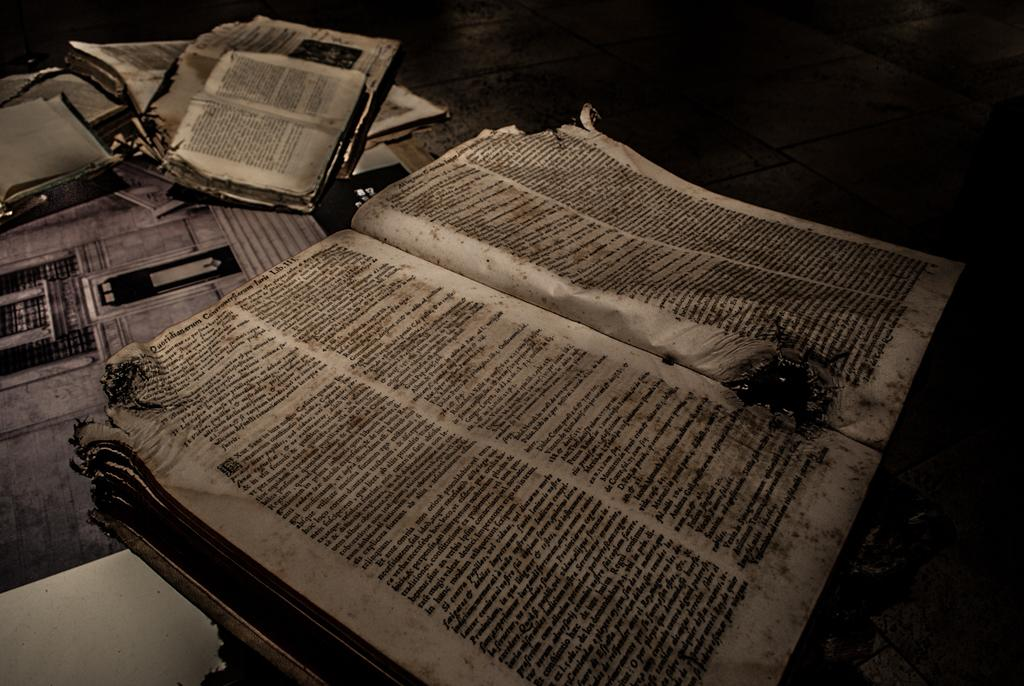Provide a one-sentence caption for the provided image. Books that look damaged are opened and the last word at the top of the left page says LIB.111. 